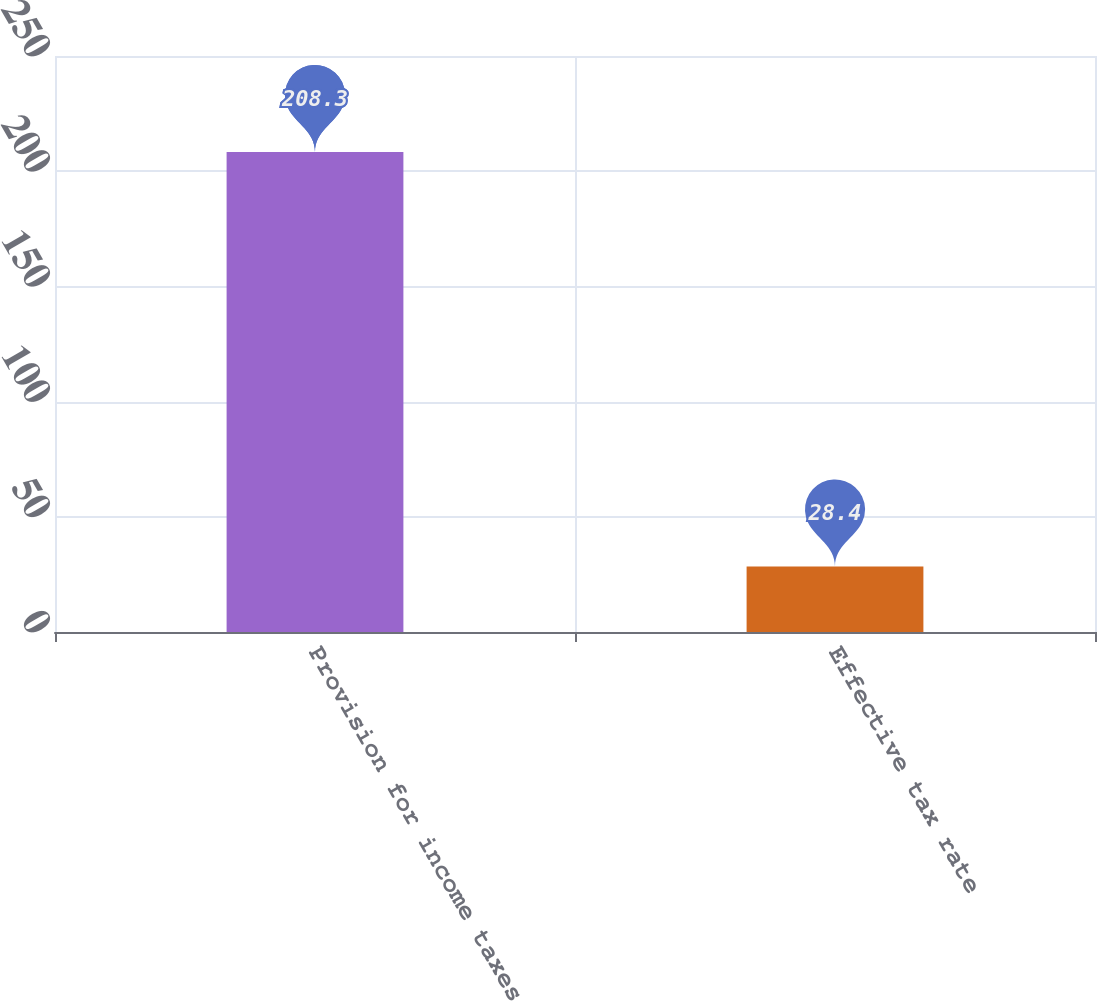Convert chart to OTSL. <chart><loc_0><loc_0><loc_500><loc_500><bar_chart><fcel>Provision for income taxes<fcel>Effective tax rate<nl><fcel>208.3<fcel>28.4<nl></chart> 